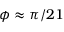<formula> <loc_0><loc_0><loc_500><loc_500>\phi \approx \pi / 2 1</formula> 